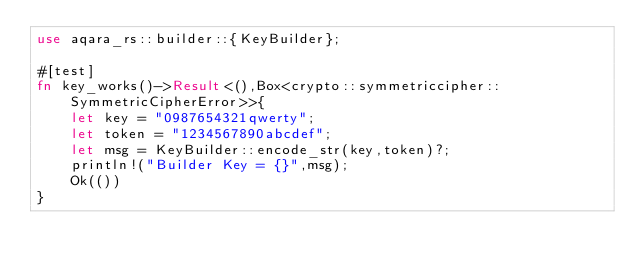Convert code to text. <code><loc_0><loc_0><loc_500><loc_500><_Rust_>use aqara_rs::builder::{KeyBuilder};

#[test]
fn key_works()->Result<(),Box<crypto::symmetriccipher::SymmetricCipherError>>{
    let key = "0987654321qwerty";
    let token = "1234567890abcdef";
    let msg = KeyBuilder::encode_str(key,token)?;
    println!("Builder Key = {}",msg);
    Ok(())
}




</code> 